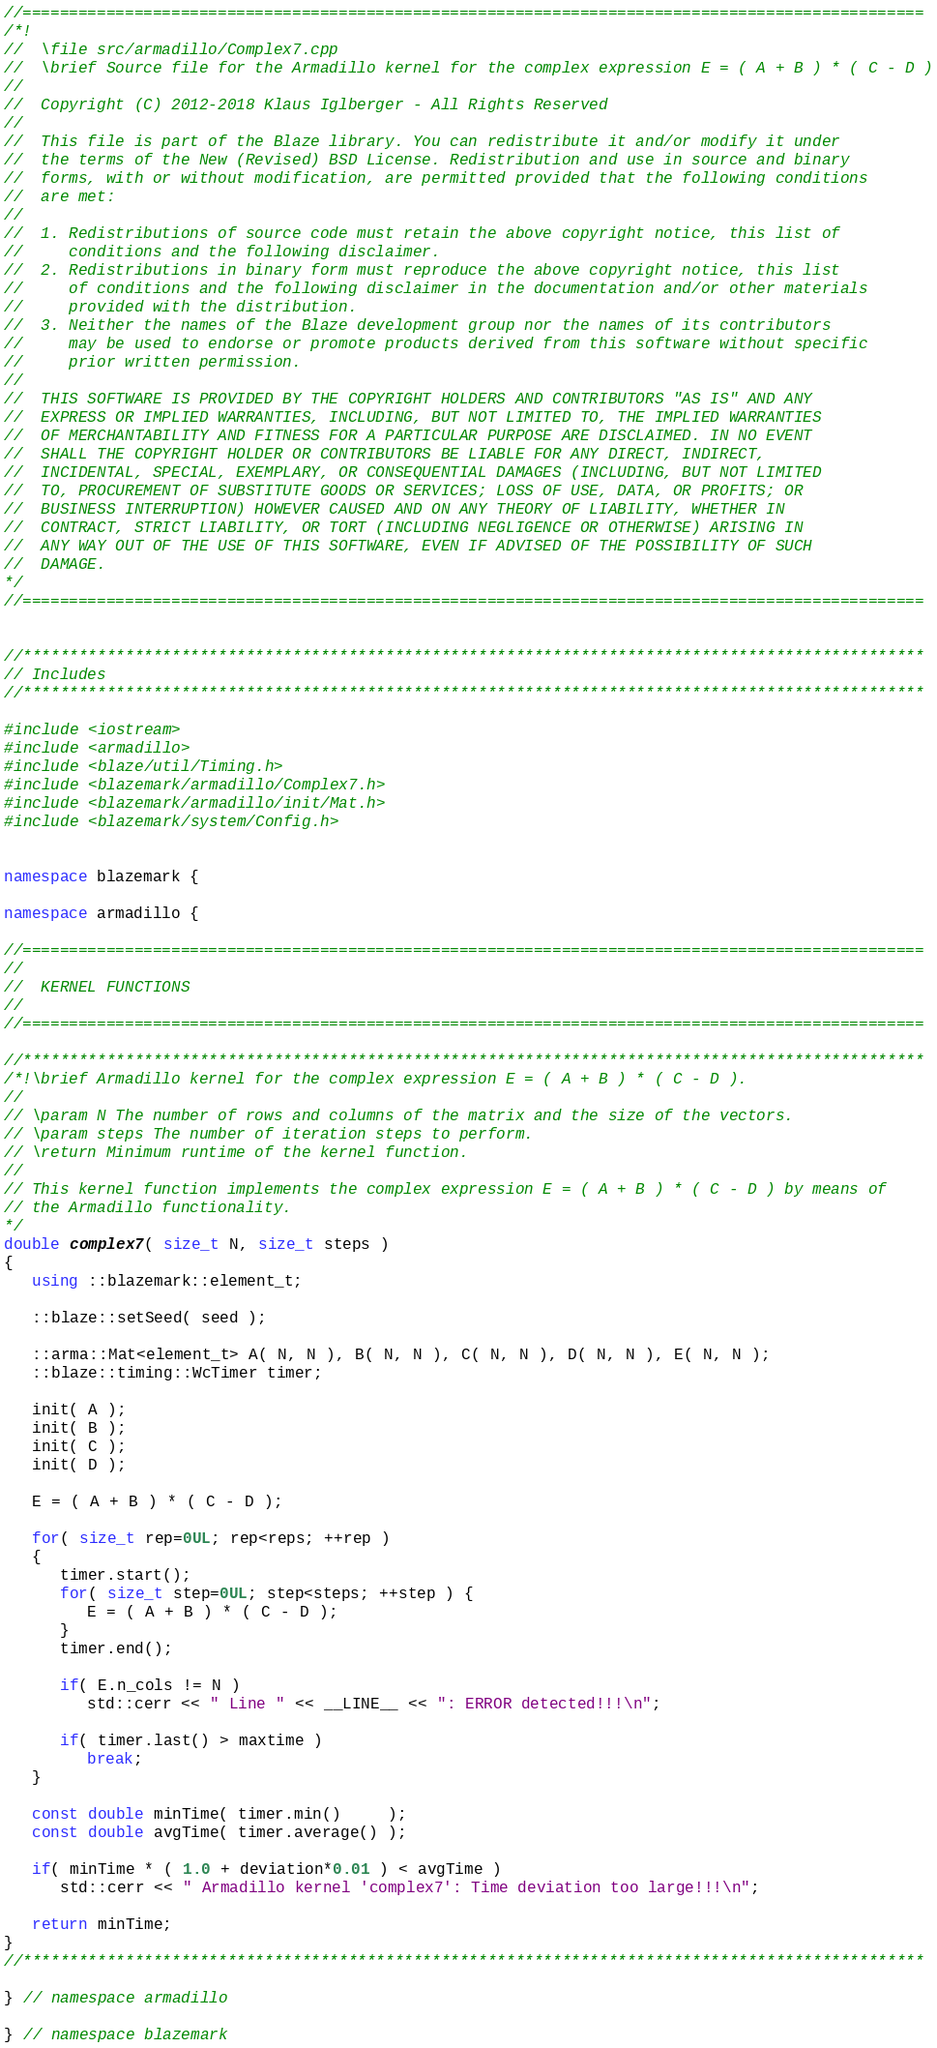<code> <loc_0><loc_0><loc_500><loc_500><_C++_>//=================================================================================================
/*!
//  \file src/armadillo/Complex7.cpp
//  \brief Source file for the Armadillo kernel for the complex expression E = ( A + B ) * ( C - D )
//
//  Copyright (C) 2012-2018 Klaus Iglberger - All Rights Reserved
//
//  This file is part of the Blaze library. You can redistribute it and/or modify it under
//  the terms of the New (Revised) BSD License. Redistribution and use in source and binary
//  forms, with or without modification, are permitted provided that the following conditions
//  are met:
//
//  1. Redistributions of source code must retain the above copyright notice, this list of
//     conditions and the following disclaimer.
//  2. Redistributions in binary form must reproduce the above copyright notice, this list
//     of conditions and the following disclaimer in the documentation and/or other materials
//     provided with the distribution.
//  3. Neither the names of the Blaze development group nor the names of its contributors
//     may be used to endorse or promote products derived from this software without specific
//     prior written permission.
//
//  THIS SOFTWARE IS PROVIDED BY THE COPYRIGHT HOLDERS AND CONTRIBUTORS "AS IS" AND ANY
//  EXPRESS OR IMPLIED WARRANTIES, INCLUDING, BUT NOT LIMITED TO, THE IMPLIED WARRANTIES
//  OF MERCHANTABILITY AND FITNESS FOR A PARTICULAR PURPOSE ARE DISCLAIMED. IN NO EVENT
//  SHALL THE COPYRIGHT HOLDER OR CONTRIBUTORS BE LIABLE FOR ANY DIRECT, INDIRECT,
//  INCIDENTAL, SPECIAL, EXEMPLARY, OR CONSEQUENTIAL DAMAGES (INCLUDING, BUT NOT LIMITED
//  TO, PROCUREMENT OF SUBSTITUTE GOODS OR SERVICES; LOSS OF USE, DATA, OR PROFITS; OR
//  BUSINESS INTERRUPTION) HOWEVER CAUSED AND ON ANY THEORY OF LIABILITY, WHETHER IN
//  CONTRACT, STRICT LIABILITY, OR TORT (INCLUDING NEGLIGENCE OR OTHERWISE) ARISING IN
//  ANY WAY OUT OF THE USE OF THIS SOFTWARE, EVEN IF ADVISED OF THE POSSIBILITY OF SUCH
//  DAMAGE.
*/
//=================================================================================================


//*************************************************************************************************
// Includes
//*************************************************************************************************

#include <iostream>
#include <armadillo>
#include <blaze/util/Timing.h>
#include <blazemark/armadillo/Complex7.h>
#include <blazemark/armadillo/init/Mat.h>
#include <blazemark/system/Config.h>


namespace blazemark {

namespace armadillo {

//=================================================================================================
//
//  KERNEL FUNCTIONS
//
//=================================================================================================

//*************************************************************************************************
/*!\brief Armadillo kernel for the complex expression E = ( A + B ) * ( C - D ).
//
// \param N The number of rows and columns of the matrix and the size of the vectors.
// \param steps The number of iteration steps to perform.
// \return Minimum runtime of the kernel function.
//
// This kernel function implements the complex expression E = ( A + B ) * ( C - D ) by means of
// the Armadillo functionality.
*/
double complex7( size_t N, size_t steps )
{
   using ::blazemark::element_t;

   ::blaze::setSeed( seed );

   ::arma::Mat<element_t> A( N, N ), B( N, N ), C( N, N ), D( N, N ), E( N, N );
   ::blaze::timing::WcTimer timer;

   init( A );
   init( B );
   init( C );
   init( D );

   E = ( A + B ) * ( C - D );

   for( size_t rep=0UL; rep<reps; ++rep )
   {
      timer.start();
      for( size_t step=0UL; step<steps; ++step ) {
         E = ( A + B ) * ( C - D );
      }
      timer.end();

      if( E.n_cols != N )
         std::cerr << " Line " << __LINE__ << ": ERROR detected!!!\n";

      if( timer.last() > maxtime )
         break;
   }

   const double minTime( timer.min()     );
   const double avgTime( timer.average() );

   if( minTime * ( 1.0 + deviation*0.01 ) < avgTime )
      std::cerr << " Armadillo kernel 'complex7': Time deviation too large!!!\n";

   return minTime;
}
//*************************************************************************************************

} // namespace armadillo

} // namespace blazemark
</code> 